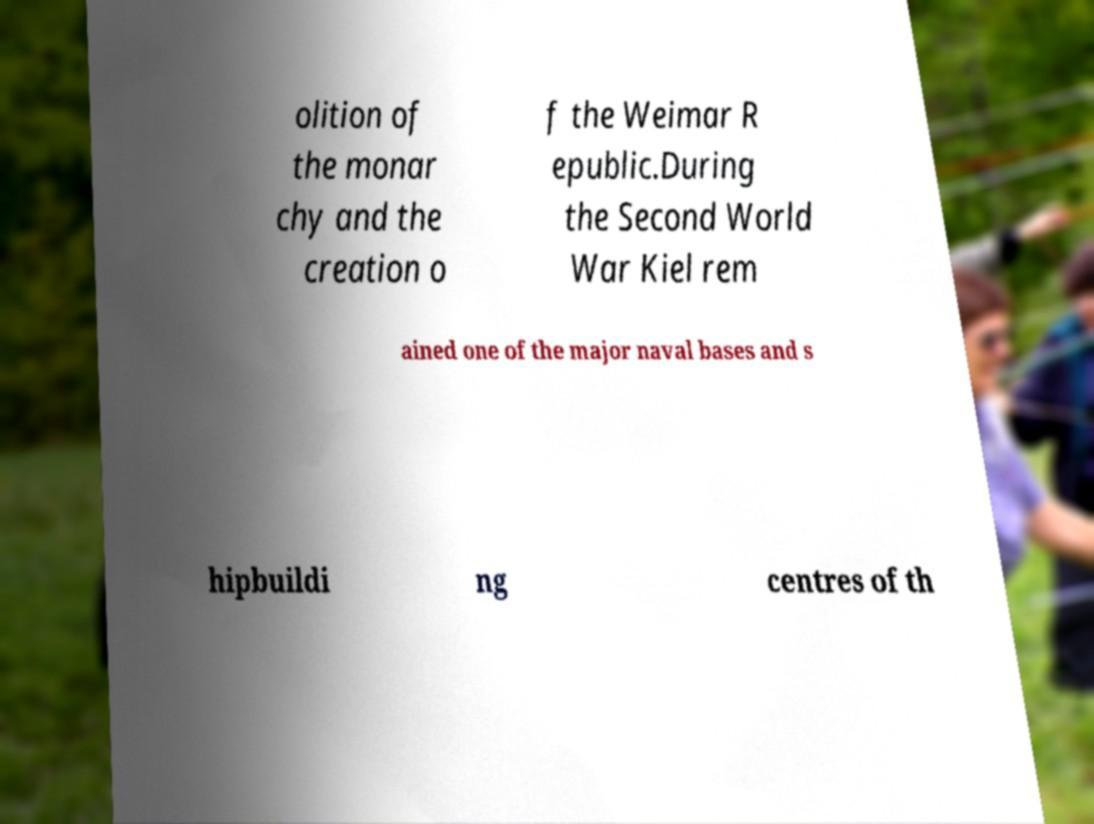Can you accurately transcribe the text from the provided image for me? olition of the monar chy and the creation o f the Weimar R epublic.During the Second World War Kiel rem ained one of the major naval bases and s hipbuildi ng centres of th 